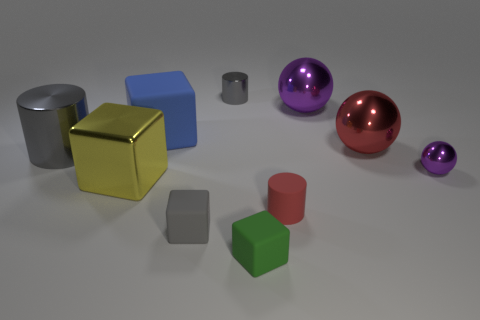Subtract all blocks. How many objects are left? 6 Subtract 0 blue cylinders. How many objects are left? 10 Subtract all large red balls. Subtract all big blue blocks. How many objects are left? 8 Add 8 gray shiny cylinders. How many gray shiny cylinders are left? 10 Add 4 red cylinders. How many red cylinders exist? 5 